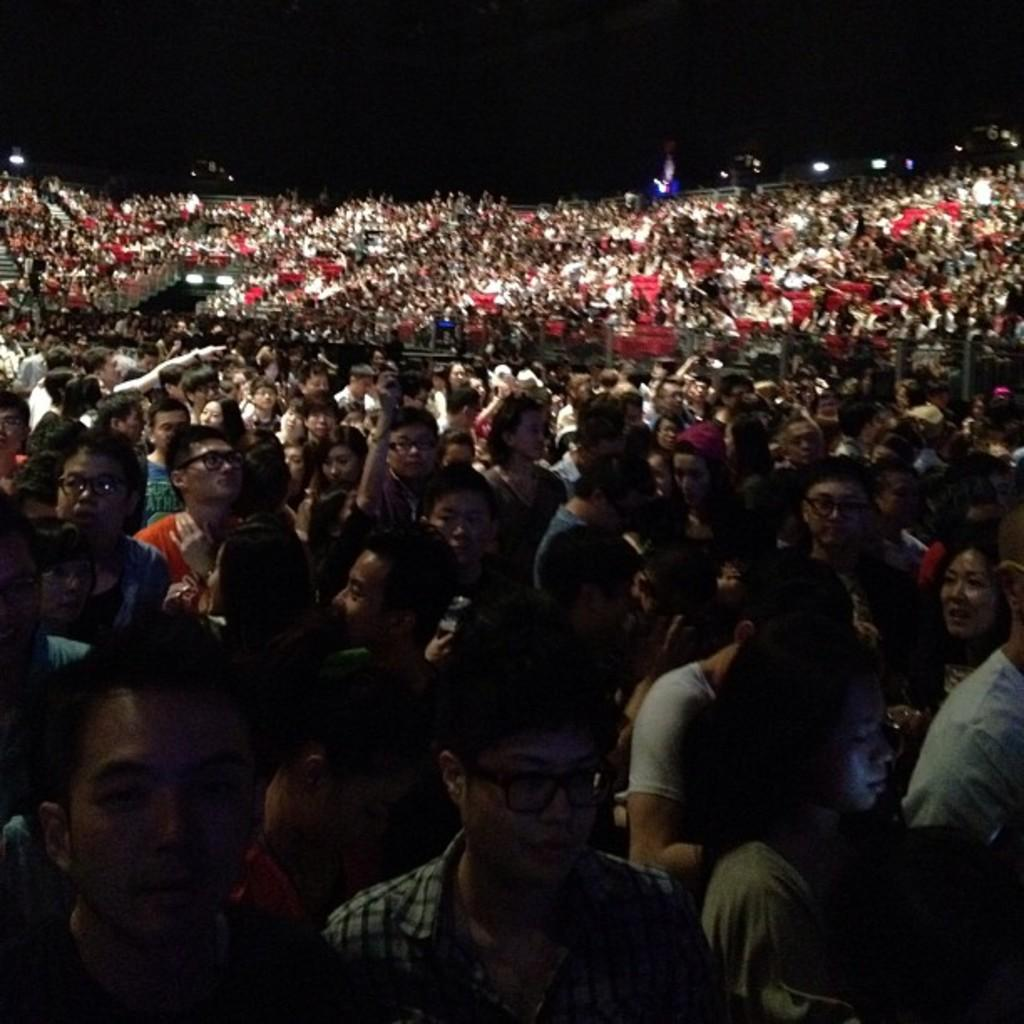What is the main subject of the image? The main subject of the image is a group of people standing in the center. Can you describe the setting of the image? The setting of the image is not specified, but there are lights visible in the background. What time does the clock show in the image? There is no clock present in the image, so it is not possible to determine the time. 